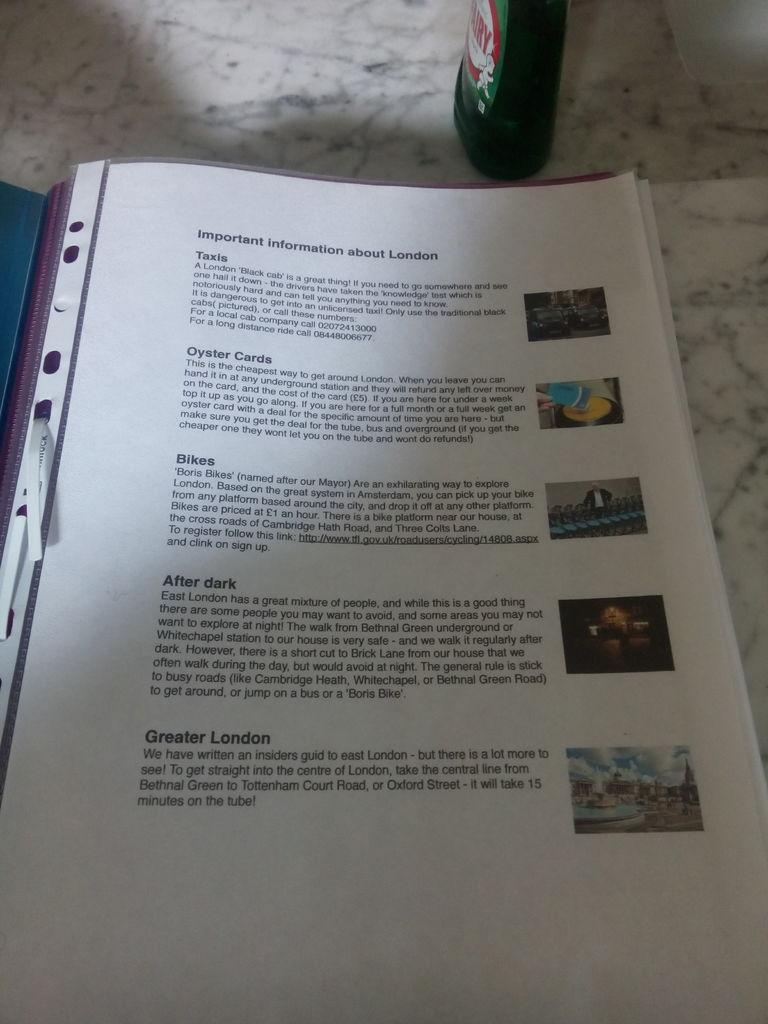What can be seen in the image that is typically used for holding liquids? There is a bottle in the image. What type of items are present on the papers in the image? There is text and images on the papers in the image. Can you describe the object on the left side of the image? The object on the left side of the image is blue in color. Where is the quartz located in the image? There is no quartz present in the image. Can you describe the fireman's actions in the image? There is no fireman present in the image. 